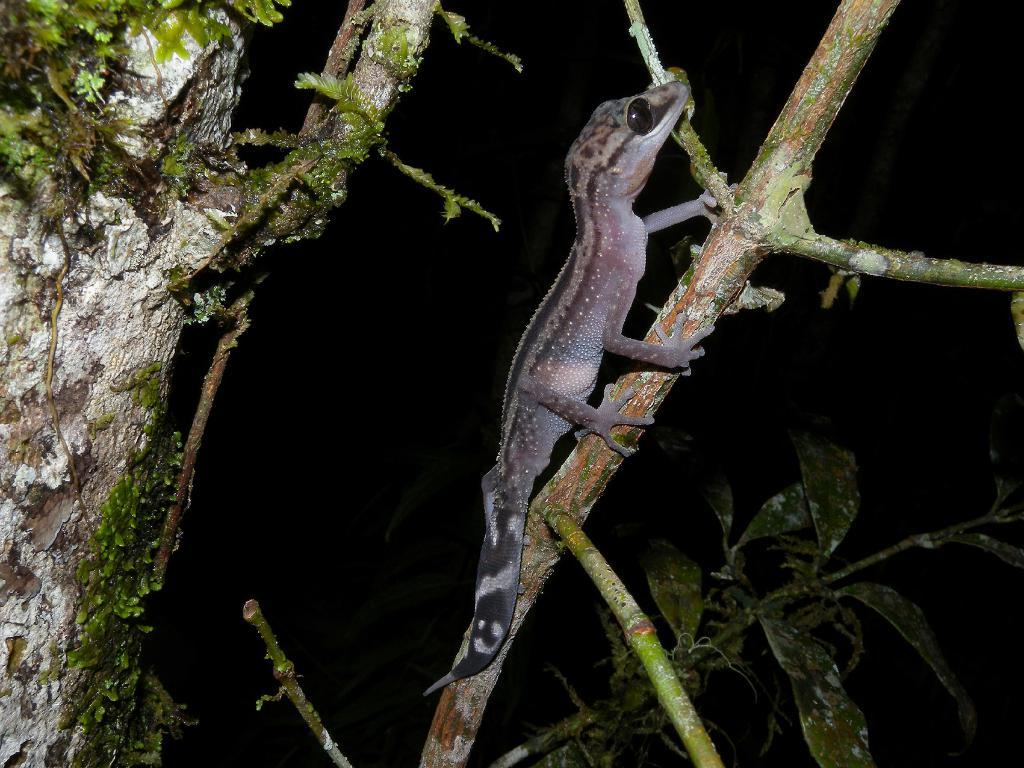What type of animal is in the image? There is a reptile in the image. Where is the reptile located? The reptile is on a tree branch. What can be seen in the image besides the reptile? There are leaves visible in the image, as well as a tree trunk. How would you describe the lighting in the image? The background of the image is dark. What part of the lettuce is visible in the image? There is no lettuce present in the image; it only features a reptile on a tree branch, leaves, and a tree trunk. 